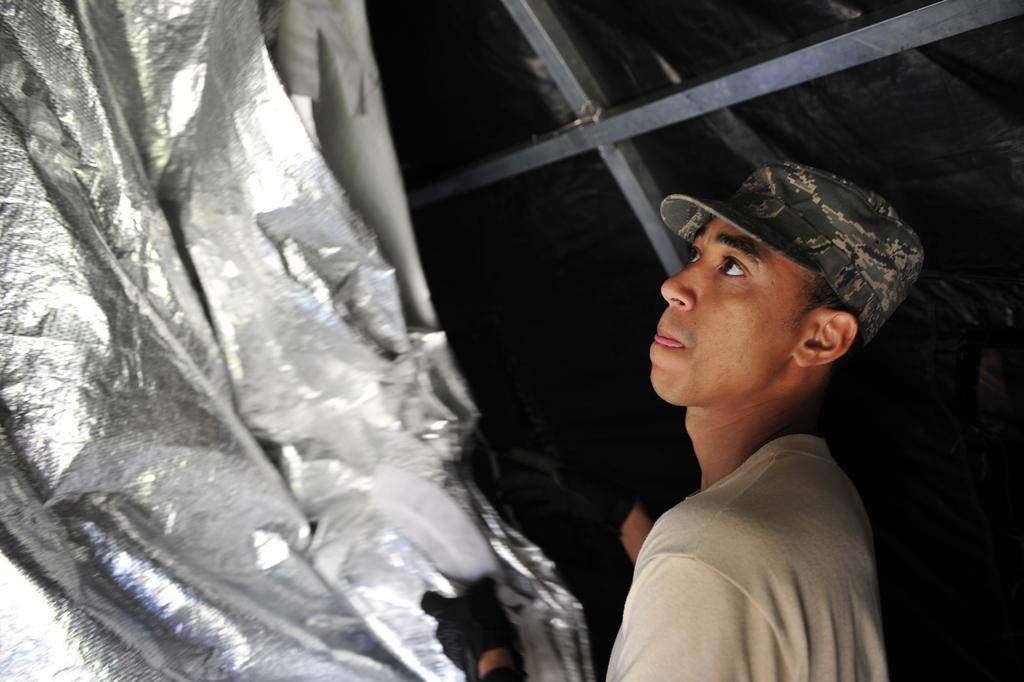Who or what can be seen in the image? There are people in the image. What type of objects are present in the image? There are metallic rods in the image. Can you describe the object on the left side of the image? Unfortunately, the provided facts do not give enough information to describe the object on the left side of the image. What is one person wearing in the image? A person is wearing a cap in the image. How many loaves of bread are visible in the image? There is no loaf of bread present in the image. What type of ants can be seen crawling on the metallic rods in the image? There are no ants present in the image; the only objects mentioned are people and metallic rods. 